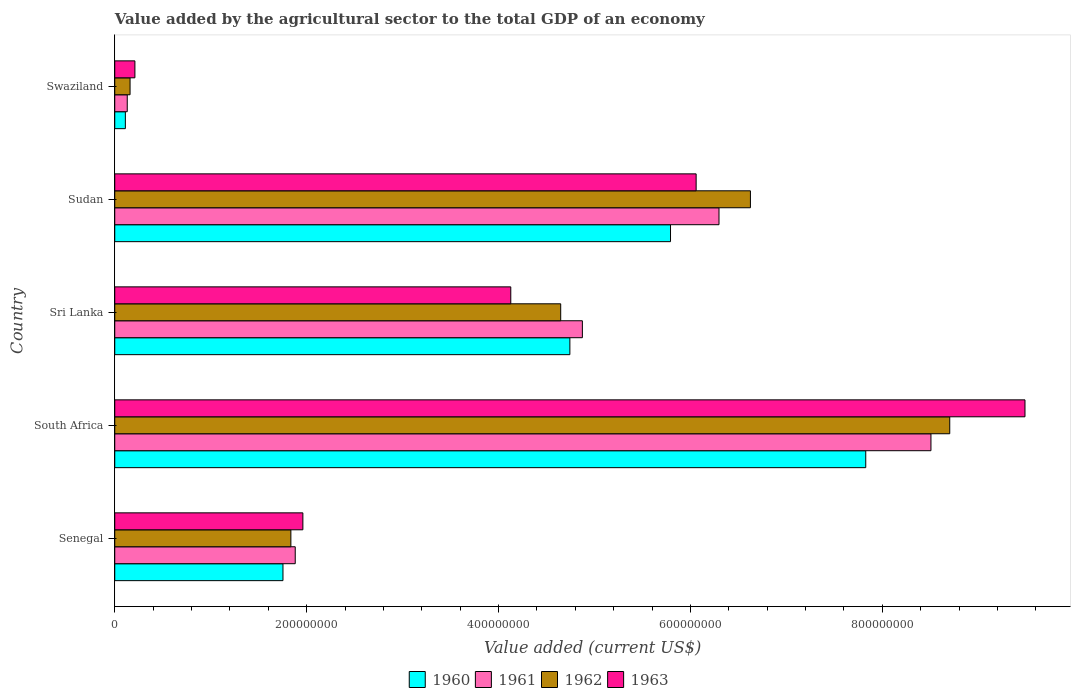How many groups of bars are there?
Offer a very short reply. 5. Are the number of bars per tick equal to the number of legend labels?
Ensure brevity in your answer.  Yes. How many bars are there on the 1st tick from the bottom?
Give a very brief answer. 4. What is the label of the 2nd group of bars from the top?
Provide a short and direct response. Sudan. In how many cases, is the number of bars for a given country not equal to the number of legend labels?
Keep it short and to the point. 0. What is the value added by the agricultural sector to the total GDP in 1961 in Swaziland?
Make the answer very short. 1.30e+07. Across all countries, what is the maximum value added by the agricultural sector to the total GDP in 1963?
Make the answer very short. 9.49e+08. Across all countries, what is the minimum value added by the agricultural sector to the total GDP in 1962?
Offer a very short reply. 1.60e+07. In which country was the value added by the agricultural sector to the total GDP in 1962 maximum?
Your response must be concise. South Africa. In which country was the value added by the agricultural sector to the total GDP in 1961 minimum?
Provide a short and direct response. Swaziland. What is the total value added by the agricultural sector to the total GDP in 1960 in the graph?
Offer a terse response. 2.02e+09. What is the difference between the value added by the agricultural sector to the total GDP in 1963 in Senegal and that in Swaziland?
Offer a very short reply. 1.75e+08. What is the difference between the value added by the agricultural sector to the total GDP in 1960 in Sudan and the value added by the agricultural sector to the total GDP in 1962 in South Africa?
Your response must be concise. -2.91e+08. What is the average value added by the agricultural sector to the total GDP in 1962 per country?
Provide a succinct answer. 4.39e+08. What is the difference between the value added by the agricultural sector to the total GDP in 1960 and value added by the agricultural sector to the total GDP in 1963 in Swaziland?
Provide a succinct answer. -9.94e+06. In how many countries, is the value added by the agricultural sector to the total GDP in 1960 greater than 760000000 US$?
Your answer should be compact. 1. What is the ratio of the value added by the agricultural sector to the total GDP in 1962 in South Africa to that in Sudan?
Ensure brevity in your answer.  1.31. Is the value added by the agricultural sector to the total GDP in 1961 in Senegal less than that in South Africa?
Your response must be concise. Yes. Is the difference between the value added by the agricultural sector to the total GDP in 1960 in South Africa and Swaziland greater than the difference between the value added by the agricultural sector to the total GDP in 1963 in South Africa and Swaziland?
Make the answer very short. No. What is the difference between the highest and the second highest value added by the agricultural sector to the total GDP in 1962?
Provide a succinct answer. 2.08e+08. What is the difference between the highest and the lowest value added by the agricultural sector to the total GDP in 1963?
Your answer should be compact. 9.28e+08. In how many countries, is the value added by the agricultural sector to the total GDP in 1963 greater than the average value added by the agricultural sector to the total GDP in 1963 taken over all countries?
Make the answer very short. 2. Is it the case that in every country, the sum of the value added by the agricultural sector to the total GDP in 1962 and value added by the agricultural sector to the total GDP in 1963 is greater than the sum of value added by the agricultural sector to the total GDP in 1960 and value added by the agricultural sector to the total GDP in 1961?
Your answer should be very brief. No. How many bars are there?
Your answer should be compact. 20. Are all the bars in the graph horizontal?
Your answer should be compact. Yes. Are the values on the major ticks of X-axis written in scientific E-notation?
Provide a succinct answer. No. Does the graph contain any zero values?
Offer a very short reply. No. How many legend labels are there?
Your answer should be compact. 4. How are the legend labels stacked?
Give a very brief answer. Horizontal. What is the title of the graph?
Offer a very short reply. Value added by the agricultural sector to the total GDP of an economy. Does "1995" appear as one of the legend labels in the graph?
Your answer should be very brief. No. What is the label or title of the X-axis?
Keep it short and to the point. Value added (current US$). What is the label or title of the Y-axis?
Offer a very short reply. Country. What is the Value added (current US$) in 1960 in Senegal?
Give a very brief answer. 1.75e+08. What is the Value added (current US$) of 1961 in Senegal?
Your response must be concise. 1.88e+08. What is the Value added (current US$) of 1962 in Senegal?
Offer a terse response. 1.84e+08. What is the Value added (current US$) of 1963 in Senegal?
Provide a short and direct response. 1.96e+08. What is the Value added (current US$) of 1960 in South Africa?
Give a very brief answer. 7.83e+08. What is the Value added (current US$) of 1961 in South Africa?
Your answer should be compact. 8.51e+08. What is the Value added (current US$) in 1962 in South Africa?
Provide a succinct answer. 8.70e+08. What is the Value added (current US$) in 1963 in South Africa?
Provide a succinct answer. 9.49e+08. What is the Value added (current US$) in 1960 in Sri Lanka?
Keep it short and to the point. 4.74e+08. What is the Value added (current US$) in 1961 in Sri Lanka?
Offer a very short reply. 4.87e+08. What is the Value added (current US$) in 1962 in Sri Lanka?
Your response must be concise. 4.65e+08. What is the Value added (current US$) of 1963 in Sri Lanka?
Give a very brief answer. 4.13e+08. What is the Value added (current US$) in 1960 in Sudan?
Provide a short and direct response. 5.79e+08. What is the Value added (current US$) of 1961 in Sudan?
Offer a terse response. 6.30e+08. What is the Value added (current US$) in 1962 in Sudan?
Ensure brevity in your answer.  6.63e+08. What is the Value added (current US$) of 1963 in Sudan?
Provide a short and direct response. 6.06e+08. What is the Value added (current US$) of 1960 in Swaziland?
Give a very brief answer. 1.11e+07. What is the Value added (current US$) in 1961 in Swaziland?
Offer a very short reply. 1.30e+07. What is the Value added (current US$) of 1962 in Swaziland?
Provide a succinct answer. 1.60e+07. What is the Value added (current US$) of 1963 in Swaziland?
Provide a succinct answer. 2.10e+07. Across all countries, what is the maximum Value added (current US$) of 1960?
Offer a very short reply. 7.83e+08. Across all countries, what is the maximum Value added (current US$) of 1961?
Your answer should be very brief. 8.51e+08. Across all countries, what is the maximum Value added (current US$) in 1962?
Give a very brief answer. 8.70e+08. Across all countries, what is the maximum Value added (current US$) in 1963?
Your answer should be very brief. 9.49e+08. Across all countries, what is the minimum Value added (current US$) of 1960?
Your answer should be very brief. 1.11e+07. Across all countries, what is the minimum Value added (current US$) of 1961?
Keep it short and to the point. 1.30e+07. Across all countries, what is the minimum Value added (current US$) of 1962?
Provide a succinct answer. 1.60e+07. Across all countries, what is the minimum Value added (current US$) in 1963?
Offer a terse response. 2.10e+07. What is the total Value added (current US$) in 1960 in the graph?
Ensure brevity in your answer.  2.02e+09. What is the total Value added (current US$) in 1961 in the graph?
Your answer should be compact. 2.17e+09. What is the total Value added (current US$) in 1962 in the graph?
Give a very brief answer. 2.20e+09. What is the total Value added (current US$) in 1963 in the graph?
Keep it short and to the point. 2.18e+09. What is the difference between the Value added (current US$) in 1960 in Senegal and that in South Africa?
Offer a terse response. -6.07e+08. What is the difference between the Value added (current US$) of 1961 in Senegal and that in South Africa?
Give a very brief answer. -6.63e+08. What is the difference between the Value added (current US$) of 1962 in Senegal and that in South Africa?
Ensure brevity in your answer.  -6.87e+08. What is the difference between the Value added (current US$) of 1963 in Senegal and that in South Africa?
Provide a succinct answer. -7.53e+08. What is the difference between the Value added (current US$) of 1960 in Senegal and that in Sri Lanka?
Your answer should be compact. -2.99e+08. What is the difference between the Value added (current US$) in 1961 in Senegal and that in Sri Lanka?
Provide a short and direct response. -2.99e+08. What is the difference between the Value added (current US$) in 1962 in Senegal and that in Sri Lanka?
Ensure brevity in your answer.  -2.81e+08. What is the difference between the Value added (current US$) in 1963 in Senegal and that in Sri Lanka?
Your response must be concise. -2.17e+08. What is the difference between the Value added (current US$) in 1960 in Senegal and that in Sudan?
Keep it short and to the point. -4.04e+08. What is the difference between the Value added (current US$) of 1961 in Senegal and that in Sudan?
Keep it short and to the point. -4.42e+08. What is the difference between the Value added (current US$) in 1962 in Senegal and that in Sudan?
Provide a succinct answer. -4.79e+08. What is the difference between the Value added (current US$) in 1963 in Senegal and that in Sudan?
Your answer should be compact. -4.10e+08. What is the difference between the Value added (current US$) of 1960 in Senegal and that in Swaziland?
Provide a succinct answer. 1.64e+08. What is the difference between the Value added (current US$) in 1961 in Senegal and that in Swaziland?
Provide a short and direct response. 1.75e+08. What is the difference between the Value added (current US$) of 1962 in Senegal and that in Swaziland?
Offer a terse response. 1.68e+08. What is the difference between the Value added (current US$) of 1963 in Senegal and that in Swaziland?
Offer a very short reply. 1.75e+08. What is the difference between the Value added (current US$) of 1960 in South Africa and that in Sri Lanka?
Offer a terse response. 3.08e+08. What is the difference between the Value added (current US$) of 1961 in South Africa and that in Sri Lanka?
Your answer should be compact. 3.63e+08. What is the difference between the Value added (current US$) in 1962 in South Africa and that in Sri Lanka?
Offer a terse response. 4.06e+08. What is the difference between the Value added (current US$) of 1963 in South Africa and that in Sri Lanka?
Ensure brevity in your answer.  5.36e+08. What is the difference between the Value added (current US$) in 1960 in South Africa and that in Sudan?
Give a very brief answer. 2.04e+08. What is the difference between the Value added (current US$) of 1961 in South Africa and that in Sudan?
Your answer should be very brief. 2.21e+08. What is the difference between the Value added (current US$) in 1962 in South Africa and that in Sudan?
Your answer should be very brief. 2.08e+08. What is the difference between the Value added (current US$) in 1963 in South Africa and that in Sudan?
Provide a succinct answer. 3.43e+08. What is the difference between the Value added (current US$) of 1960 in South Africa and that in Swaziland?
Provide a succinct answer. 7.72e+08. What is the difference between the Value added (current US$) of 1961 in South Africa and that in Swaziland?
Offer a very short reply. 8.38e+08. What is the difference between the Value added (current US$) in 1962 in South Africa and that in Swaziland?
Your answer should be very brief. 8.54e+08. What is the difference between the Value added (current US$) in 1963 in South Africa and that in Swaziland?
Offer a very short reply. 9.28e+08. What is the difference between the Value added (current US$) of 1960 in Sri Lanka and that in Sudan?
Provide a succinct answer. -1.05e+08. What is the difference between the Value added (current US$) in 1961 in Sri Lanka and that in Sudan?
Provide a succinct answer. -1.42e+08. What is the difference between the Value added (current US$) of 1962 in Sri Lanka and that in Sudan?
Provide a succinct answer. -1.98e+08. What is the difference between the Value added (current US$) in 1963 in Sri Lanka and that in Sudan?
Offer a terse response. -1.93e+08. What is the difference between the Value added (current US$) of 1960 in Sri Lanka and that in Swaziland?
Your answer should be compact. 4.63e+08. What is the difference between the Value added (current US$) of 1961 in Sri Lanka and that in Swaziland?
Make the answer very short. 4.74e+08. What is the difference between the Value added (current US$) of 1962 in Sri Lanka and that in Swaziland?
Keep it short and to the point. 4.49e+08. What is the difference between the Value added (current US$) in 1963 in Sri Lanka and that in Swaziland?
Your answer should be compact. 3.92e+08. What is the difference between the Value added (current US$) in 1960 in Sudan and that in Swaziland?
Your response must be concise. 5.68e+08. What is the difference between the Value added (current US$) in 1961 in Sudan and that in Swaziland?
Provide a short and direct response. 6.17e+08. What is the difference between the Value added (current US$) of 1962 in Sudan and that in Swaziland?
Your answer should be compact. 6.47e+08. What is the difference between the Value added (current US$) in 1963 in Sudan and that in Swaziland?
Provide a succinct answer. 5.85e+08. What is the difference between the Value added (current US$) of 1960 in Senegal and the Value added (current US$) of 1961 in South Africa?
Provide a succinct answer. -6.75e+08. What is the difference between the Value added (current US$) of 1960 in Senegal and the Value added (current US$) of 1962 in South Africa?
Give a very brief answer. -6.95e+08. What is the difference between the Value added (current US$) of 1960 in Senegal and the Value added (current US$) of 1963 in South Africa?
Offer a terse response. -7.73e+08. What is the difference between the Value added (current US$) in 1961 in Senegal and the Value added (current US$) in 1962 in South Africa?
Your answer should be very brief. -6.82e+08. What is the difference between the Value added (current US$) of 1961 in Senegal and the Value added (current US$) of 1963 in South Africa?
Make the answer very short. -7.61e+08. What is the difference between the Value added (current US$) in 1962 in Senegal and the Value added (current US$) in 1963 in South Africa?
Make the answer very short. -7.65e+08. What is the difference between the Value added (current US$) in 1960 in Senegal and the Value added (current US$) in 1961 in Sri Lanka?
Provide a short and direct response. -3.12e+08. What is the difference between the Value added (current US$) of 1960 in Senegal and the Value added (current US$) of 1962 in Sri Lanka?
Provide a short and direct response. -2.89e+08. What is the difference between the Value added (current US$) in 1960 in Senegal and the Value added (current US$) in 1963 in Sri Lanka?
Give a very brief answer. -2.37e+08. What is the difference between the Value added (current US$) of 1961 in Senegal and the Value added (current US$) of 1962 in Sri Lanka?
Your response must be concise. -2.77e+08. What is the difference between the Value added (current US$) of 1961 in Senegal and the Value added (current US$) of 1963 in Sri Lanka?
Your answer should be compact. -2.25e+08. What is the difference between the Value added (current US$) in 1962 in Senegal and the Value added (current US$) in 1963 in Sri Lanka?
Ensure brevity in your answer.  -2.29e+08. What is the difference between the Value added (current US$) of 1960 in Senegal and the Value added (current US$) of 1961 in Sudan?
Make the answer very short. -4.54e+08. What is the difference between the Value added (current US$) in 1960 in Senegal and the Value added (current US$) in 1962 in Sudan?
Keep it short and to the point. -4.87e+08. What is the difference between the Value added (current US$) of 1960 in Senegal and the Value added (current US$) of 1963 in Sudan?
Offer a terse response. -4.31e+08. What is the difference between the Value added (current US$) in 1961 in Senegal and the Value added (current US$) in 1962 in Sudan?
Ensure brevity in your answer.  -4.74e+08. What is the difference between the Value added (current US$) in 1961 in Senegal and the Value added (current US$) in 1963 in Sudan?
Provide a succinct answer. -4.18e+08. What is the difference between the Value added (current US$) of 1962 in Senegal and the Value added (current US$) of 1963 in Sudan?
Your answer should be very brief. -4.22e+08. What is the difference between the Value added (current US$) of 1960 in Senegal and the Value added (current US$) of 1961 in Swaziland?
Ensure brevity in your answer.  1.62e+08. What is the difference between the Value added (current US$) in 1960 in Senegal and the Value added (current US$) in 1962 in Swaziland?
Your response must be concise. 1.59e+08. What is the difference between the Value added (current US$) in 1960 in Senegal and the Value added (current US$) in 1963 in Swaziland?
Provide a short and direct response. 1.54e+08. What is the difference between the Value added (current US$) in 1961 in Senegal and the Value added (current US$) in 1962 in Swaziland?
Ensure brevity in your answer.  1.72e+08. What is the difference between the Value added (current US$) in 1961 in Senegal and the Value added (current US$) in 1963 in Swaziland?
Your answer should be compact. 1.67e+08. What is the difference between the Value added (current US$) of 1962 in Senegal and the Value added (current US$) of 1963 in Swaziland?
Make the answer very short. 1.63e+08. What is the difference between the Value added (current US$) of 1960 in South Africa and the Value added (current US$) of 1961 in Sri Lanka?
Provide a succinct answer. 2.95e+08. What is the difference between the Value added (current US$) in 1960 in South Africa and the Value added (current US$) in 1962 in Sri Lanka?
Keep it short and to the point. 3.18e+08. What is the difference between the Value added (current US$) in 1960 in South Africa and the Value added (current US$) in 1963 in Sri Lanka?
Your answer should be compact. 3.70e+08. What is the difference between the Value added (current US$) of 1961 in South Africa and the Value added (current US$) of 1962 in Sri Lanka?
Provide a succinct answer. 3.86e+08. What is the difference between the Value added (current US$) of 1961 in South Africa and the Value added (current US$) of 1963 in Sri Lanka?
Provide a succinct answer. 4.38e+08. What is the difference between the Value added (current US$) of 1962 in South Africa and the Value added (current US$) of 1963 in Sri Lanka?
Your answer should be very brief. 4.58e+08. What is the difference between the Value added (current US$) of 1960 in South Africa and the Value added (current US$) of 1961 in Sudan?
Your answer should be compact. 1.53e+08. What is the difference between the Value added (current US$) in 1960 in South Africa and the Value added (current US$) in 1962 in Sudan?
Ensure brevity in your answer.  1.20e+08. What is the difference between the Value added (current US$) in 1960 in South Africa and the Value added (current US$) in 1963 in Sudan?
Your answer should be compact. 1.77e+08. What is the difference between the Value added (current US$) in 1961 in South Africa and the Value added (current US$) in 1962 in Sudan?
Give a very brief answer. 1.88e+08. What is the difference between the Value added (current US$) in 1961 in South Africa and the Value added (current US$) in 1963 in Sudan?
Offer a terse response. 2.45e+08. What is the difference between the Value added (current US$) of 1962 in South Africa and the Value added (current US$) of 1963 in Sudan?
Provide a short and direct response. 2.64e+08. What is the difference between the Value added (current US$) of 1960 in South Africa and the Value added (current US$) of 1961 in Swaziland?
Provide a short and direct response. 7.70e+08. What is the difference between the Value added (current US$) of 1960 in South Africa and the Value added (current US$) of 1962 in Swaziland?
Your answer should be very brief. 7.67e+08. What is the difference between the Value added (current US$) of 1960 in South Africa and the Value added (current US$) of 1963 in Swaziland?
Provide a short and direct response. 7.62e+08. What is the difference between the Value added (current US$) of 1961 in South Africa and the Value added (current US$) of 1962 in Swaziland?
Provide a short and direct response. 8.35e+08. What is the difference between the Value added (current US$) of 1961 in South Africa and the Value added (current US$) of 1963 in Swaziland?
Keep it short and to the point. 8.30e+08. What is the difference between the Value added (current US$) of 1962 in South Africa and the Value added (current US$) of 1963 in Swaziland?
Provide a short and direct response. 8.49e+08. What is the difference between the Value added (current US$) of 1960 in Sri Lanka and the Value added (current US$) of 1961 in Sudan?
Provide a short and direct response. -1.55e+08. What is the difference between the Value added (current US$) in 1960 in Sri Lanka and the Value added (current US$) in 1962 in Sudan?
Your response must be concise. -1.88e+08. What is the difference between the Value added (current US$) in 1960 in Sri Lanka and the Value added (current US$) in 1963 in Sudan?
Make the answer very short. -1.32e+08. What is the difference between the Value added (current US$) of 1961 in Sri Lanka and the Value added (current US$) of 1962 in Sudan?
Keep it short and to the point. -1.75e+08. What is the difference between the Value added (current US$) of 1961 in Sri Lanka and the Value added (current US$) of 1963 in Sudan?
Make the answer very short. -1.19e+08. What is the difference between the Value added (current US$) of 1962 in Sri Lanka and the Value added (current US$) of 1963 in Sudan?
Your answer should be compact. -1.41e+08. What is the difference between the Value added (current US$) in 1960 in Sri Lanka and the Value added (current US$) in 1961 in Swaziland?
Your answer should be very brief. 4.61e+08. What is the difference between the Value added (current US$) of 1960 in Sri Lanka and the Value added (current US$) of 1962 in Swaziland?
Your answer should be compact. 4.58e+08. What is the difference between the Value added (current US$) in 1960 in Sri Lanka and the Value added (current US$) in 1963 in Swaziland?
Provide a succinct answer. 4.53e+08. What is the difference between the Value added (current US$) of 1961 in Sri Lanka and the Value added (current US$) of 1962 in Swaziland?
Offer a terse response. 4.71e+08. What is the difference between the Value added (current US$) in 1961 in Sri Lanka and the Value added (current US$) in 1963 in Swaziland?
Offer a very short reply. 4.66e+08. What is the difference between the Value added (current US$) of 1962 in Sri Lanka and the Value added (current US$) of 1963 in Swaziland?
Make the answer very short. 4.44e+08. What is the difference between the Value added (current US$) of 1960 in Sudan and the Value added (current US$) of 1961 in Swaziland?
Provide a short and direct response. 5.66e+08. What is the difference between the Value added (current US$) of 1960 in Sudan and the Value added (current US$) of 1962 in Swaziland?
Your response must be concise. 5.63e+08. What is the difference between the Value added (current US$) of 1960 in Sudan and the Value added (current US$) of 1963 in Swaziland?
Offer a terse response. 5.58e+08. What is the difference between the Value added (current US$) of 1961 in Sudan and the Value added (current US$) of 1962 in Swaziland?
Make the answer very short. 6.14e+08. What is the difference between the Value added (current US$) in 1961 in Sudan and the Value added (current US$) in 1963 in Swaziland?
Provide a short and direct response. 6.09e+08. What is the difference between the Value added (current US$) of 1962 in Sudan and the Value added (current US$) of 1963 in Swaziland?
Provide a succinct answer. 6.42e+08. What is the average Value added (current US$) of 1960 per country?
Your answer should be very brief. 4.05e+08. What is the average Value added (current US$) in 1961 per country?
Provide a succinct answer. 4.34e+08. What is the average Value added (current US$) in 1962 per country?
Ensure brevity in your answer.  4.39e+08. What is the average Value added (current US$) in 1963 per country?
Provide a succinct answer. 4.37e+08. What is the difference between the Value added (current US$) in 1960 and Value added (current US$) in 1961 in Senegal?
Offer a terse response. -1.28e+07. What is the difference between the Value added (current US$) of 1960 and Value added (current US$) of 1962 in Senegal?
Ensure brevity in your answer.  -8.24e+06. What is the difference between the Value added (current US$) in 1960 and Value added (current US$) in 1963 in Senegal?
Your answer should be very brief. -2.07e+07. What is the difference between the Value added (current US$) in 1961 and Value added (current US$) in 1962 in Senegal?
Your answer should be compact. 4.54e+06. What is the difference between the Value added (current US$) of 1961 and Value added (current US$) of 1963 in Senegal?
Your answer should be very brief. -7.96e+06. What is the difference between the Value added (current US$) of 1962 and Value added (current US$) of 1963 in Senegal?
Provide a short and direct response. -1.25e+07. What is the difference between the Value added (current US$) in 1960 and Value added (current US$) in 1961 in South Africa?
Your response must be concise. -6.80e+07. What is the difference between the Value added (current US$) in 1960 and Value added (current US$) in 1962 in South Africa?
Your answer should be very brief. -8.76e+07. What is the difference between the Value added (current US$) in 1960 and Value added (current US$) in 1963 in South Africa?
Make the answer very short. -1.66e+08. What is the difference between the Value added (current US$) of 1961 and Value added (current US$) of 1962 in South Africa?
Make the answer very short. -1.96e+07. What is the difference between the Value added (current US$) of 1961 and Value added (current US$) of 1963 in South Africa?
Offer a terse response. -9.80e+07. What is the difference between the Value added (current US$) in 1962 and Value added (current US$) in 1963 in South Africa?
Your response must be concise. -7.84e+07. What is the difference between the Value added (current US$) of 1960 and Value added (current US$) of 1961 in Sri Lanka?
Your response must be concise. -1.30e+07. What is the difference between the Value added (current US$) in 1960 and Value added (current US$) in 1962 in Sri Lanka?
Your response must be concise. 9.55e+06. What is the difference between the Value added (current US$) of 1960 and Value added (current US$) of 1963 in Sri Lanka?
Your response must be concise. 6.16e+07. What is the difference between the Value added (current US$) of 1961 and Value added (current US$) of 1962 in Sri Lanka?
Your response must be concise. 2.26e+07. What is the difference between the Value added (current US$) in 1961 and Value added (current US$) in 1963 in Sri Lanka?
Offer a terse response. 7.46e+07. What is the difference between the Value added (current US$) of 1962 and Value added (current US$) of 1963 in Sri Lanka?
Provide a succinct answer. 5.20e+07. What is the difference between the Value added (current US$) of 1960 and Value added (current US$) of 1961 in Sudan?
Offer a very short reply. -5.05e+07. What is the difference between the Value added (current US$) of 1960 and Value added (current US$) of 1962 in Sudan?
Your answer should be compact. -8.33e+07. What is the difference between the Value added (current US$) in 1960 and Value added (current US$) in 1963 in Sudan?
Keep it short and to the point. -2.67e+07. What is the difference between the Value added (current US$) of 1961 and Value added (current US$) of 1962 in Sudan?
Ensure brevity in your answer.  -3.27e+07. What is the difference between the Value added (current US$) of 1961 and Value added (current US$) of 1963 in Sudan?
Your answer should be very brief. 2.38e+07. What is the difference between the Value added (current US$) in 1962 and Value added (current US$) in 1963 in Sudan?
Offer a terse response. 5.66e+07. What is the difference between the Value added (current US$) in 1960 and Value added (current US$) in 1961 in Swaziland?
Your answer should be compact. -1.96e+06. What is the difference between the Value added (current US$) of 1960 and Value added (current US$) of 1962 in Swaziland?
Offer a terse response. -4.90e+06. What is the difference between the Value added (current US$) in 1960 and Value added (current US$) in 1963 in Swaziland?
Provide a succinct answer. -9.94e+06. What is the difference between the Value added (current US$) in 1961 and Value added (current US$) in 1962 in Swaziland?
Offer a very short reply. -2.94e+06. What is the difference between the Value added (current US$) of 1961 and Value added (current US$) of 1963 in Swaziland?
Your response must be concise. -7.98e+06. What is the difference between the Value added (current US$) of 1962 and Value added (current US$) of 1963 in Swaziland?
Your answer should be very brief. -5.04e+06. What is the ratio of the Value added (current US$) of 1960 in Senegal to that in South Africa?
Offer a terse response. 0.22. What is the ratio of the Value added (current US$) of 1961 in Senegal to that in South Africa?
Keep it short and to the point. 0.22. What is the ratio of the Value added (current US$) in 1962 in Senegal to that in South Africa?
Give a very brief answer. 0.21. What is the ratio of the Value added (current US$) of 1963 in Senegal to that in South Africa?
Offer a terse response. 0.21. What is the ratio of the Value added (current US$) of 1960 in Senegal to that in Sri Lanka?
Offer a terse response. 0.37. What is the ratio of the Value added (current US$) in 1961 in Senegal to that in Sri Lanka?
Ensure brevity in your answer.  0.39. What is the ratio of the Value added (current US$) of 1962 in Senegal to that in Sri Lanka?
Ensure brevity in your answer.  0.39. What is the ratio of the Value added (current US$) in 1963 in Senegal to that in Sri Lanka?
Offer a very short reply. 0.47. What is the ratio of the Value added (current US$) of 1960 in Senegal to that in Sudan?
Offer a terse response. 0.3. What is the ratio of the Value added (current US$) in 1961 in Senegal to that in Sudan?
Provide a short and direct response. 0.3. What is the ratio of the Value added (current US$) in 1962 in Senegal to that in Sudan?
Offer a very short reply. 0.28. What is the ratio of the Value added (current US$) of 1963 in Senegal to that in Sudan?
Offer a terse response. 0.32. What is the ratio of the Value added (current US$) of 1960 in Senegal to that in Swaziland?
Provide a short and direct response. 15.85. What is the ratio of the Value added (current US$) in 1961 in Senegal to that in Swaziland?
Make the answer very short. 14.45. What is the ratio of the Value added (current US$) in 1962 in Senegal to that in Swaziland?
Give a very brief answer. 11.5. What is the ratio of the Value added (current US$) of 1963 in Senegal to that in Swaziland?
Ensure brevity in your answer.  9.34. What is the ratio of the Value added (current US$) of 1960 in South Africa to that in Sri Lanka?
Offer a very short reply. 1.65. What is the ratio of the Value added (current US$) of 1961 in South Africa to that in Sri Lanka?
Offer a terse response. 1.75. What is the ratio of the Value added (current US$) in 1962 in South Africa to that in Sri Lanka?
Offer a terse response. 1.87. What is the ratio of the Value added (current US$) of 1963 in South Africa to that in Sri Lanka?
Your answer should be very brief. 2.3. What is the ratio of the Value added (current US$) in 1960 in South Africa to that in Sudan?
Your answer should be compact. 1.35. What is the ratio of the Value added (current US$) of 1961 in South Africa to that in Sudan?
Make the answer very short. 1.35. What is the ratio of the Value added (current US$) in 1962 in South Africa to that in Sudan?
Offer a very short reply. 1.31. What is the ratio of the Value added (current US$) of 1963 in South Africa to that in Sudan?
Provide a short and direct response. 1.57. What is the ratio of the Value added (current US$) in 1960 in South Africa to that in Swaziland?
Keep it short and to the point. 70.77. What is the ratio of the Value added (current US$) in 1961 in South Africa to that in Swaziland?
Your response must be concise. 65.34. What is the ratio of the Value added (current US$) of 1962 in South Africa to that in Swaziland?
Ensure brevity in your answer.  54.53. What is the ratio of the Value added (current US$) of 1963 in South Africa to that in Swaziland?
Make the answer very short. 45.18. What is the ratio of the Value added (current US$) of 1960 in Sri Lanka to that in Sudan?
Offer a terse response. 0.82. What is the ratio of the Value added (current US$) in 1961 in Sri Lanka to that in Sudan?
Ensure brevity in your answer.  0.77. What is the ratio of the Value added (current US$) of 1962 in Sri Lanka to that in Sudan?
Ensure brevity in your answer.  0.7. What is the ratio of the Value added (current US$) of 1963 in Sri Lanka to that in Sudan?
Ensure brevity in your answer.  0.68. What is the ratio of the Value added (current US$) of 1960 in Sri Lanka to that in Swaziland?
Keep it short and to the point. 42.89. What is the ratio of the Value added (current US$) of 1961 in Sri Lanka to that in Swaziland?
Offer a terse response. 37.43. What is the ratio of the Value added (current US$) in 1962 in Sri Lanka to that in Swaziland?
Keep it short and to the point. 29.12. What is the ratio of the Value added (current US$) in 1963 in Sri Lanka to that in Swaziland?
Your answer should be very brief. 19.66. What is the ratio of the Value added (current US$) of 1960 in Sudan to that in Swaziland?
Offer a terse response. 52.37. What is the ratio of the Value added (current US$) of 1961 in Sudan to that in Swaziland?
Your answer should be very brief. 48.37. What is the ratio of the Value added (current US$) of 1962 in Sudan to that in Swaziland?
Offer a terse response. 41.51. What is the ratio of the Value added (current US$) in 1963 in Sudan to that in Swaziland?
Provide a short and direct response. 28.86. What is the difference between the highest and the second highest Value added (current US$) in 1960?
Your answer should be very brief. 2.04e+08. What is the difference between the highest and the second highest Value added (current US$) in 1961?
Your answer should be very brief. 2.21e+08. What is the difference between the highest and the second highest Value added (current US$) of 1962?
Your answer should be very brief. 2.08e+08. What is the difference between the highest and the second highest Value added (current US$) in 1963?
Your answer should be compact. 3.43e+08. What is the difference between the highest and the lowest Value added (current US$) in 1960?
Provide a succinct answer. 7.72e+08. What is the difference between the highest and the lowest Value added (current US$) in 1961?
Keep it short and to the point. 8.38e+08. What is the difference between the highest and the lowest Value added (current US$) in 1962?
Offer a terse response. 8.54e+08. What is the difference between the highest and the lowest Value added (current US$) in 1963?
Offer a terse response. 9.28e+08. 